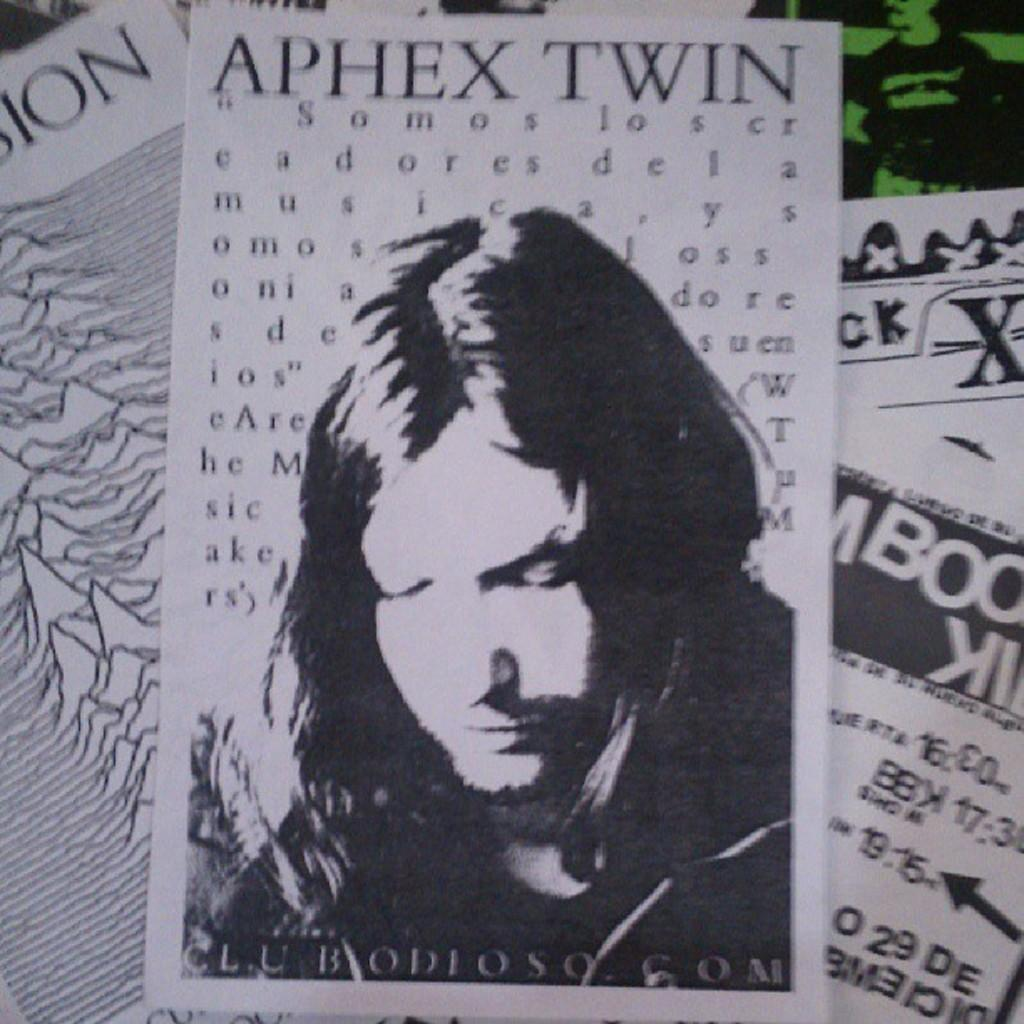What can be seen on the papers in the image? There are papers in the image, and there is writing on them. Is there any other visual element on the papers besides the writing? Yes, there is an image of a person on the papers. How many fingers can be seen on the person's hand in the image? There is no person's hand visible in the image, only an image of a person on the papers. Are there any ants crawling on the papers in the image? There are no ants present in the image. 